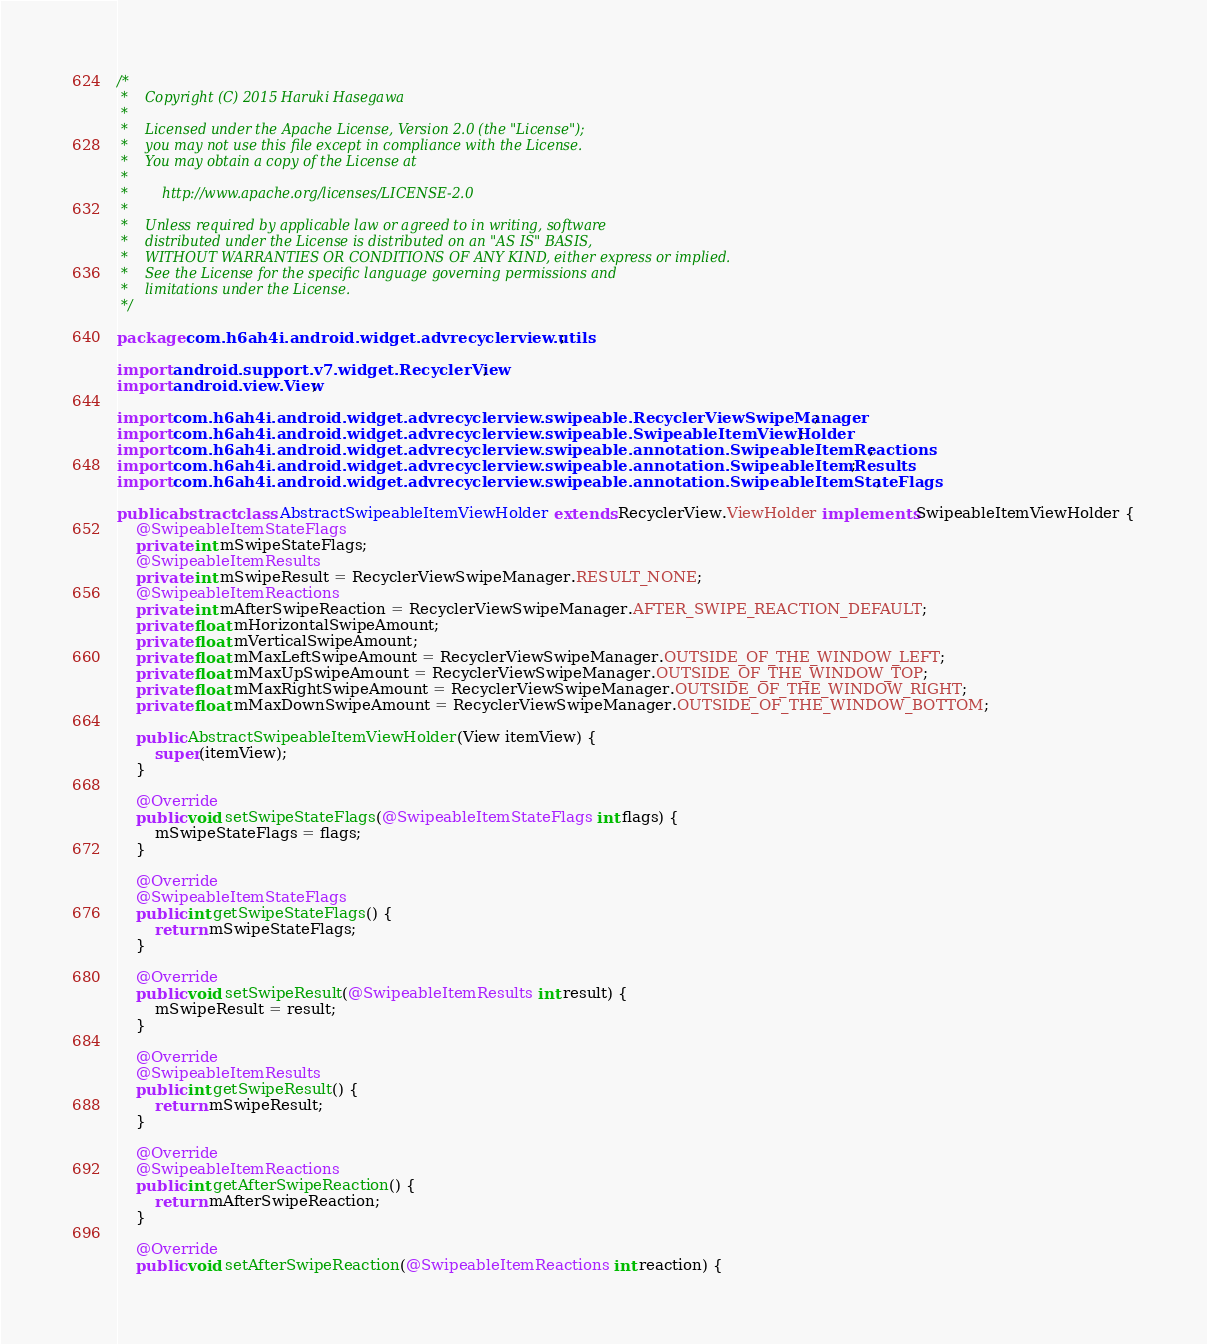<code> <loc_0><loc_0><loc_500><loc_500><_Java_>/*
 *    Copyright (C) 2015 Haruki Hasegawa
 *
 *    Licensed under the Apache License, Version 2.0 (the "License");
 *    you may not use this file except in compliance with the License.
 *    You may obtain a copy of the License at
 *
 *        http://www.apache.org/licenses/LICENSE-2.0
 *
 *    Unless required by applicable law or agreed to in writing, software
 *    distributed under the License is distributed on an "AS IS" BASIS,
 *    WITHOUT WARRANTIES OR CONDITIONS OF ANY KIND, either express or implied.
 *    See the License for the specific language governing permissions and
 *    limitations under the License.
 */

package com.h6ah4i.android.widget.advrecyclerview.utils;

import android.support.v7.widget.RecyclerView;
import android.view.View;

import com.h6ah4i.android.widget.advrecyclerview.swipeable.RecyclerViewSwipeManager;
import com.h6ah4i.android.widget.advrecyclerview.swipeable.SwipeableItemViewHolder;
import com.h6ah4i.android.widget.advrecyclerview.swipeable.annotation.SwipeableItemReactions;
import com.h6ah4i.android.widget.advrecyclerview.swipeable.annotation.SwipeableItemResults;
import com.h6ah4i.android.widget.advrecyclerview.swipeable.annotation.SwipeableItemStateFlags;

public abstract class AbstractSwipeableItemViewHolder extends RecyclerView.ViewHolder implements SwipeableItemViewHolder {
    @SwipeableItemStateFlags
    private int mSwipeStateFlags;
    @SwipeableItemResults
    private int mSwipeResult = RecyclerViewSwipeManager.RESULT_NONE;
    @SwipeableItemReactions
    private int mAfterSwipeReaction = RecyclerViewSwipeManager.AFTER_SWIPE_REACTION_DEFAULT;
    private float mHorizontalSwipeAmount;
    private float mVerticalSwipeAmount;
    private float mMaxLeftSwipeAmount = RecyclerViewSwipeManager.OUTSIDE_OF_THE_WINDOW_LEFT;
    private float mMaxUpSwipeAmount = RecyclerViewSwipeManager.OUTSIDE_OF_THE_WINDOW_TOP;
    private float mMaxRightSwipeAmount = RecyclerViewSwipeManager.OUTSIDE_OF_THE_WINDOW_RIGHT;
    private float mMaxDownSwipeAmount = RecyclerViewSwipeManager.OUTSIDE_OF_THE_WINDOW_BOTTOM;

    public AbstractSwipeableItemViewHolder(View itemView) {
        super(itemView);
    }

    @Override
    public void setSwipeStateFlags(@SwipeableItemStateFlags int flags) {
        mSwipeStateFlags = flags;
    }

    @Override
    @SwipeableItemStateFlags
    public int getSwipeStateFlags() {
        return mSwipeStateFlags;
    }

    @Override
    public void setSwipeResult(@SwipeableItemResults int result) {
        mSwipeResult = result;
    }

    @Override
    @SwipeableItemResults
    public int getSwipeResult() {
        return mSwipeResult;
    }

    @Override
    @SwipeableItemReactions
    public int getAfterSwipeReaction() {
        return mAfterSwipeReaction;
    }

    @Override
    public void setAfterSwipeReaction(@SwipeableItemReactions int reaction) {</code> 